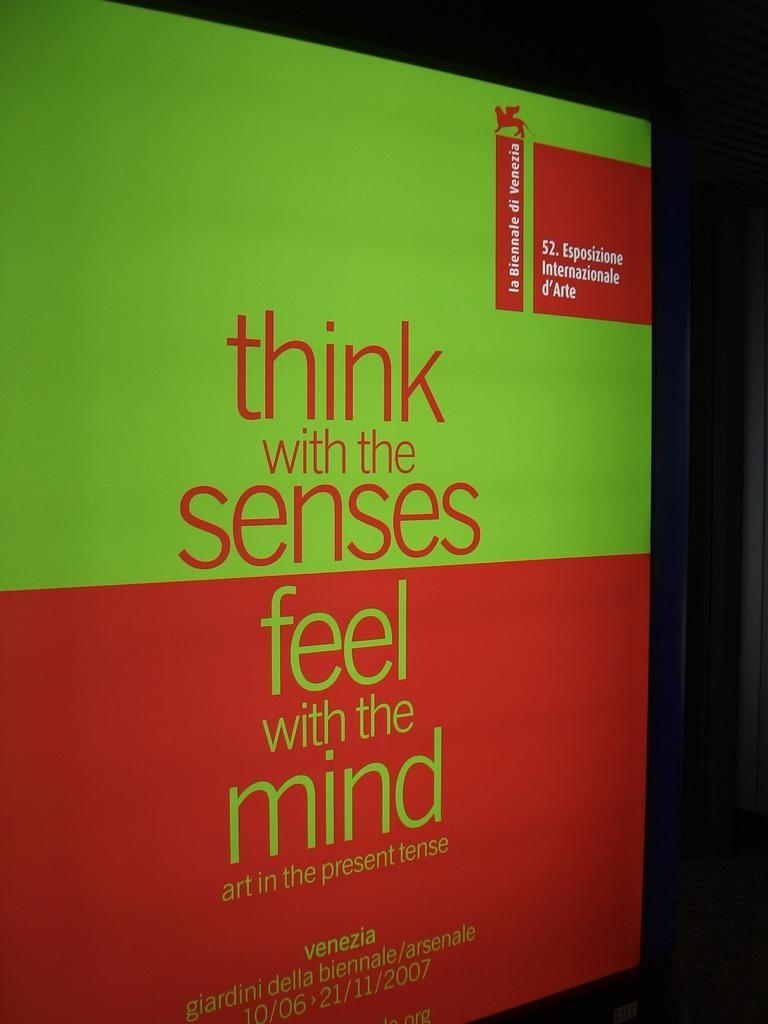<image>
Offer a succinct explanation of the picture presented. Green and red book that says Think with the senses. 